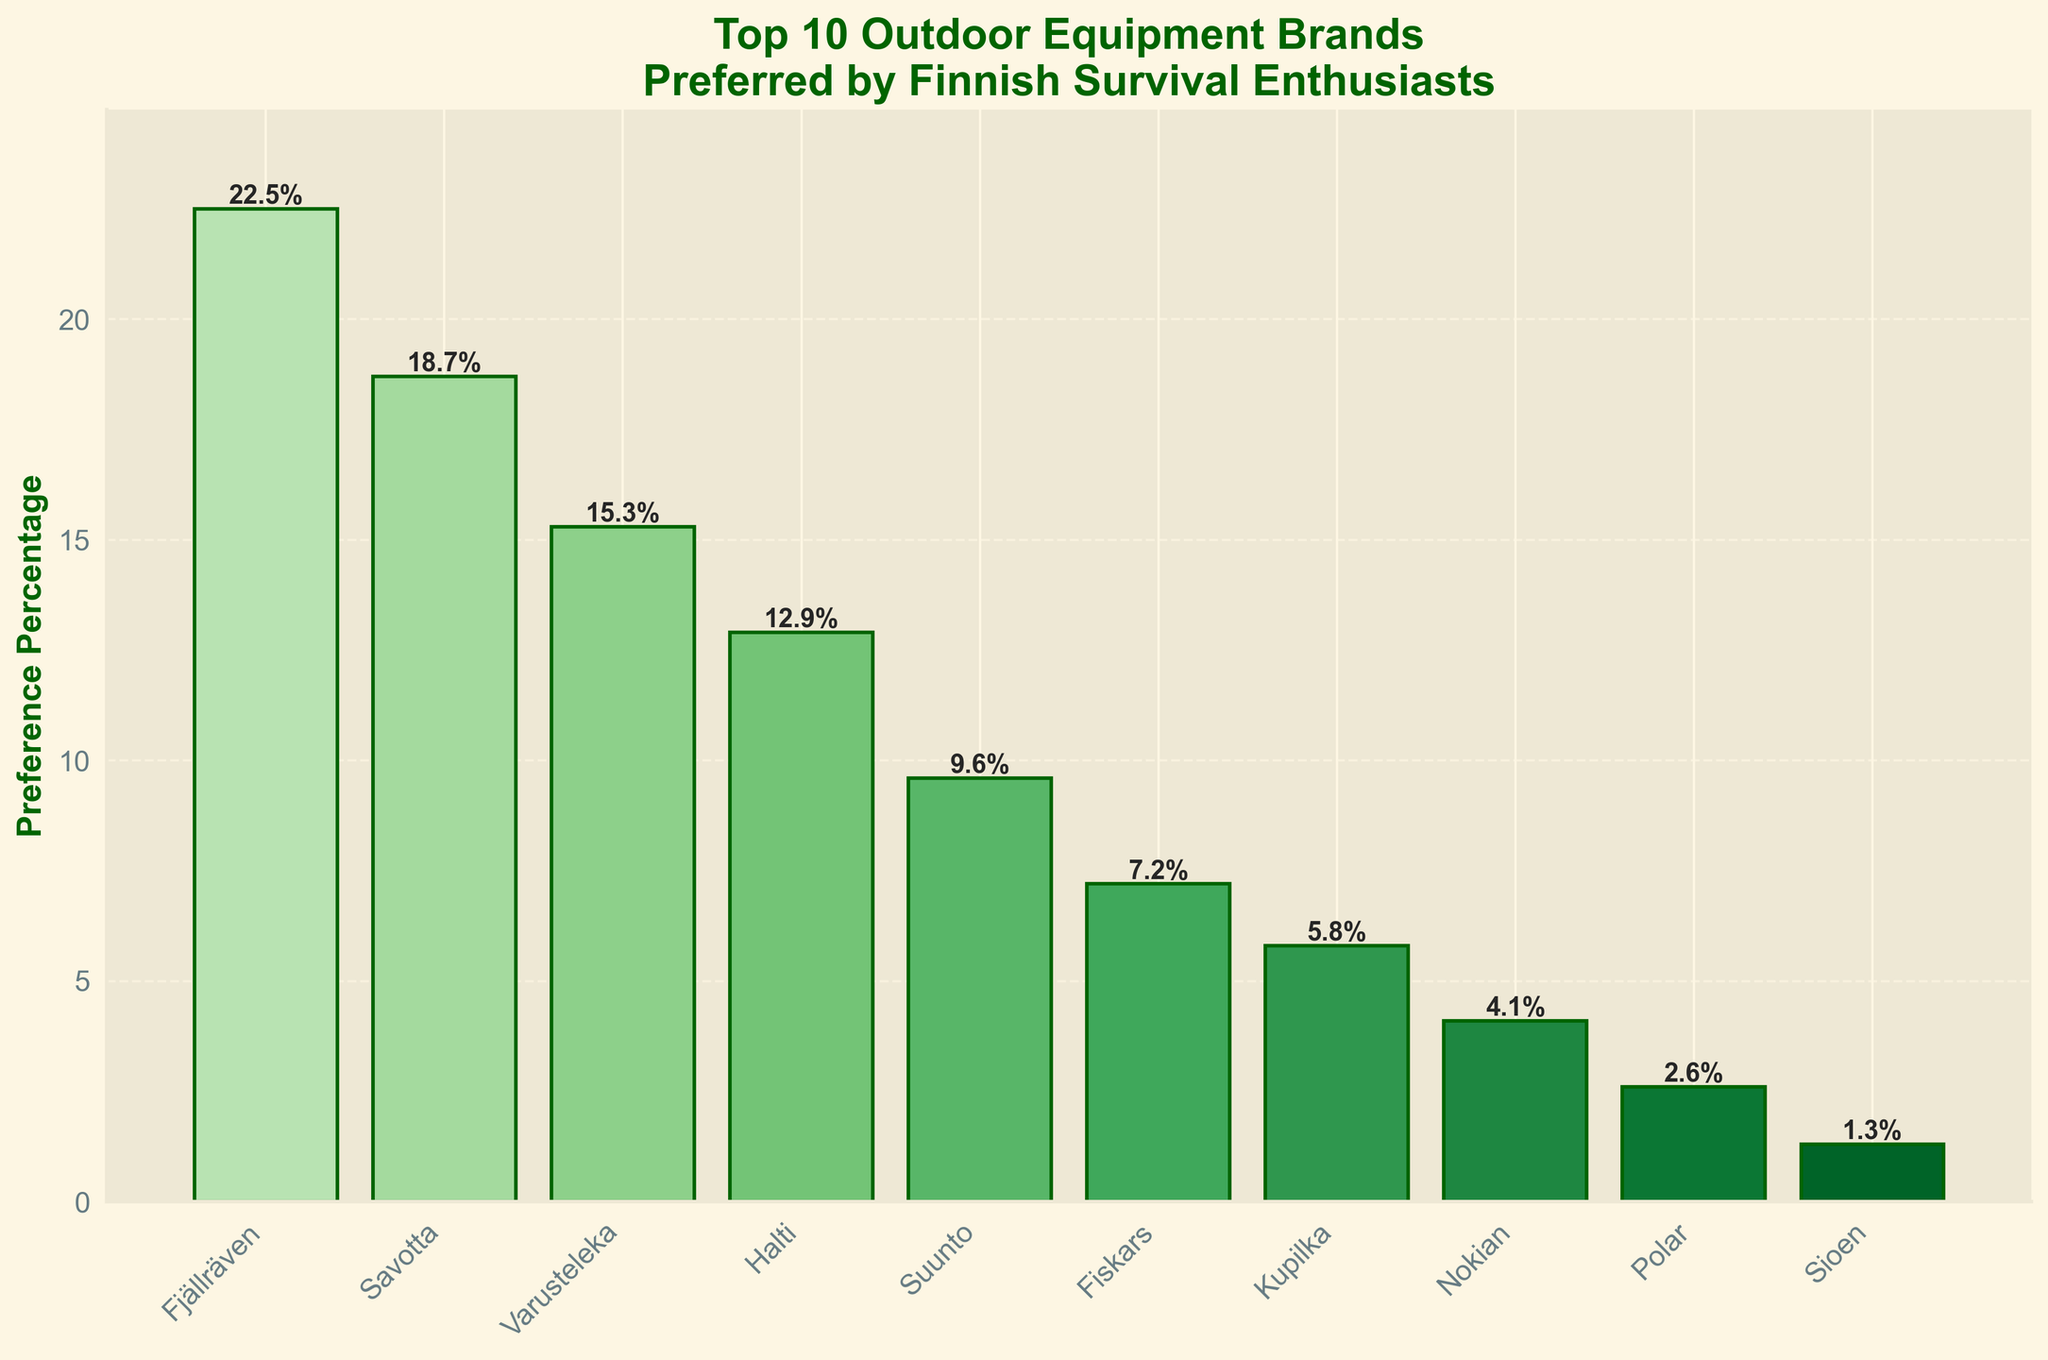What is the most preferred outdoor equipment brand among Finnish survival enthusiasts? The brand with the highest preference percentage is the most preferred. According to the figure, Fjällräven has the highest percentage.
Answer: Fjällräven Which brand has a higher preference percentage, Varusteleka or Fiskars? We compare the preference percentages of Varusteleka (15.3%) and Fiskars (7.2%). Varusteleka has a higher percentage.
Answer: Varusteleka What is the total preference percentage for the top three brands? The top three brands are Fjällräven (22.5%), Savotta (18.7%), and Varusteleka (15.3%). The total percentage is 22.5 + 18.7 + 15.3 = 56.5%.
Answer: 56.5% How many brands have a preference percentage that is less than 10%? To determine this, identify brands with preference percentages below 10%: Suunto (9.6%), Fiskars (7.2%), Kupilka (5.8%), Nokian (4.1%), Polar (2.6%), and Sioen (1.3%). There are 6 such brands.
Answer: 6 Which brand has the lowest preference percentage? The brand with the lowest preference percentage according to the figure is Sioen with 1.3%.
Answer: Sioen What's the difference in preference percentage between Halti and Nokian? Subtract Nokian's percentage (4.1%) from Halti's percentage (12.9%): 12.9 - 4.1 = 8.8%.
Answer: 8.8% What's the average preference percentage of all the brands? Sum all preference percentages and divide by the number of brands: (22.5 + 18.7 + 15.3 + 12.9 + 9.6 + 7.2 + 5.8 + 4.1 + 2.6 + 1.3) / 10 = 10%.
Answer: 10% What is the combined preference percentage of Savotta, Suunto, and Polar? Sum the percentages of these brands: Savotta (18.7%) + Suunto (9.6%) + Polar (2.6%) = 30.9%.
Answer: 30.9% Which brands have preference percentages within 10% to 20%? Look for brands whose percentages fall between 10% and 20%. These are Savotta (18.7%), Varusteleka (15.3%), and Halti (12.9%).
Answer: Savotta, Varusteleka, Halti How does the height and color of the bar representing Fjällräven compare with that of Sioen? Fjällräven's bar is both taller and a darker shade of green compared to Sioen's bar.
Answer: Taller and darker green 